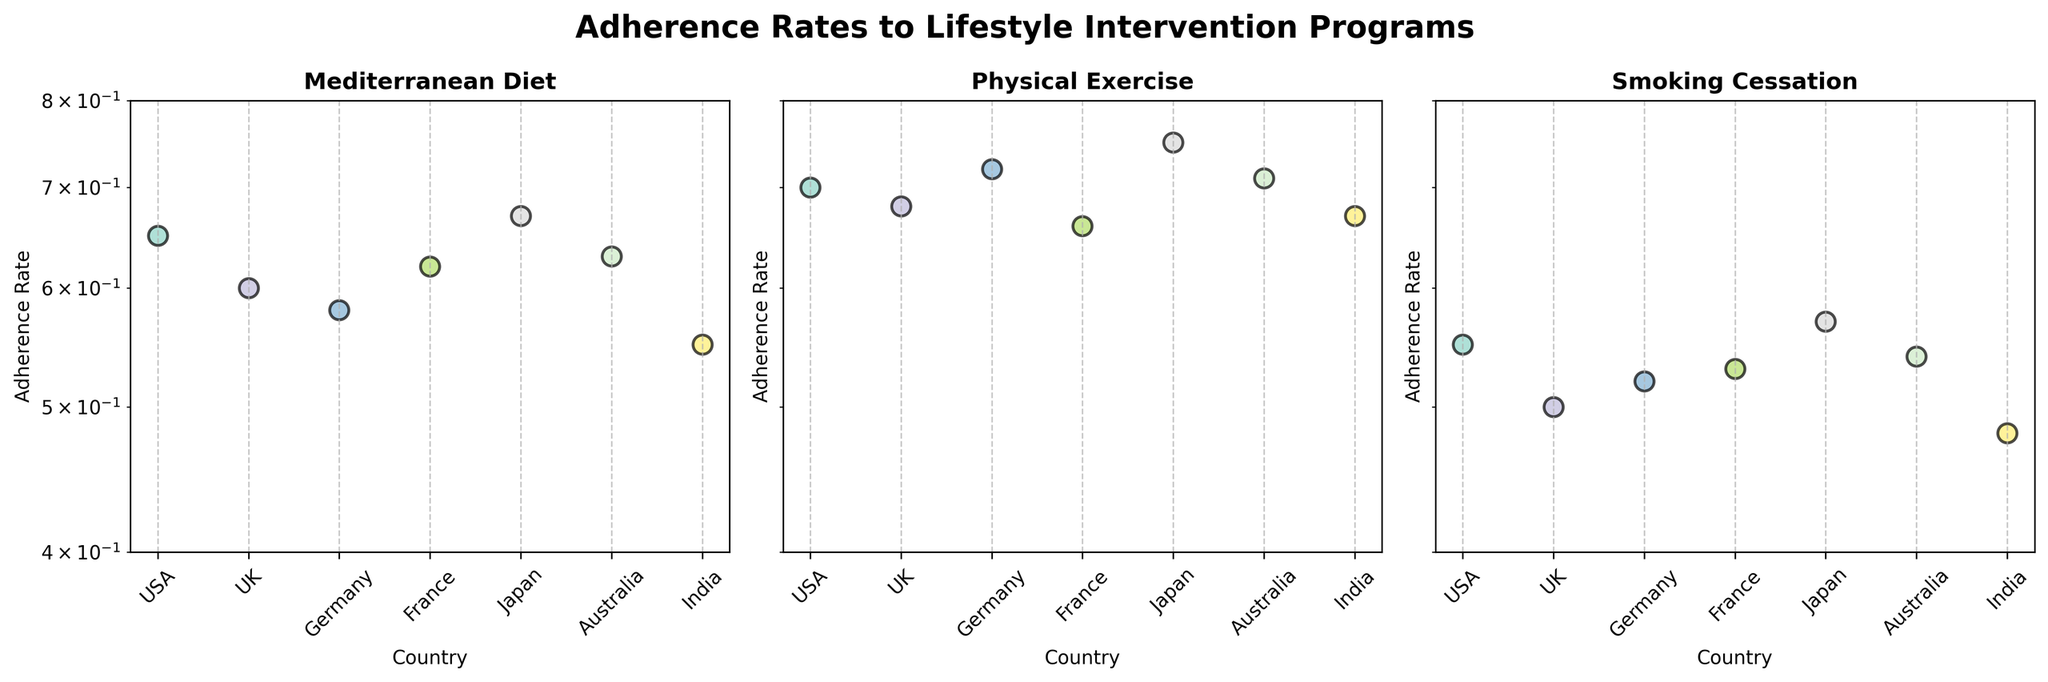What's the title of the figure? The title is typically the largest text at the top of the figure. Here, it reads "Adherence Rates to Lifestyle Intervention Programs".
Answer: Adherence Rates to Lifestyle Intervention Programs Which country has the highest adherence rate for the Physical Exercise program? Look at the Physical Exercise subplot, identify the highest point, and find the corresponding country. The highest point in that subplot corresponds to Japan.
Answer: Japan How many unique countries are represented in the figure? Each subplot has the same x-axis values, representing countries. By checking one of the subplots, we see USA, UK, Germany, France, Japan, Australia, and India, making a total of 7 unique countries.
Answer: 7 Which program has the highest adherence rate across all countries? Check the maximum adhering rate data points in each subplot. The highest value across all subplots appears in the Physical Exercise subplot where Japan has an adherence rate of 0.75.
Answer: Physical Exercise What is the adherence rate range displayed on the y-axis? The y-axis is logarithmic and spans from just below 0.4 to 0.8, as indicated on each subplot.
Answer: 0.4 to 0.8 Which country has the lowest adherence rate for the Smoking Cessation program? In the Smoking Cessation subplot, identify the lowest point and its corresponding country. The lowest point belongs to India with an adherence rate of 0.48.
Answer: India What are the adherence rates for the Mediterranean Diet program in Japan and Australia? Check the Mediterranean Diet subplot and locate the data points for Japan and Australia. Japan has an adherence rate of 0.67, and Australia has a rate of 0.63.
Answer: 0.67 and 0.63 Compare the adherence rates for Physical Exercise between the USA and Germany. Which country has a higher adherence rate? In the Physical Exercise subplot, locate the points for USA and Germany. The USA has a rate of 0.70, and Germany has a higher rate of 0.72.
Answer: Germany Which lifestyle intervention program shows the most variation in adherence rates across different countries? Look for the program subplot with the widest spread in adherence rates. The Smoking Cessation subplot shows the most variation, with adherence rates ranging from 0.48 in India to 0.57 in Japan.
Answer: Smoking Cessation Are there any two programs that have countries showing equal adherence rates within the figure? Check across the three subplots to see if any adherence rates match exactly for one country between different programs. In this case, no adherence rates match exactly between different programs for any country.
Answer: No 